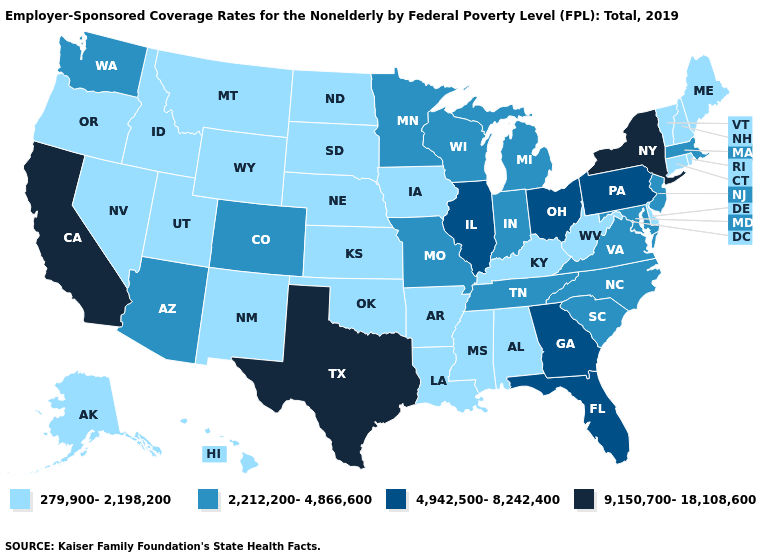Does Louisiana have the lowest value in the South?
Be succinct. Yes. Name the states that have a value in the range 279,900-2,198,200?
Give a very brief answer. Alabama, Alaska, Arkansas, Connecticut, Delaware, Hawaii, Idaho, Iowa, Kansas, Kentucky, Louisiana, Maine, Mississippi, Montana, Nebraska, Nevada, New Hampshire, New Mexico, North Dakota, Oklahoma, Oregon, Rhode Island, South Dakota, Utah, Vermont, West Virginia, Wyoming. What is the value of Iowa?
Concise answer only. 279,900-2,198,200. Name the states that have a value in the range 2,212,200-4,866,600?
Answer briefly. Arizona, Colorado, Indiana, Maryland, Massachusetts, Michigan, Minnesota, Missouri, New Jersey, North Carolina, South Carolina, Tennessee, Virginia, Washington, Wisconsin. What is the value of North Dakota?
Write a very short answer. 279,900-2,198,200. What is the lowest value in states that border Montana?
Quick response, please. 279,900-2,198,200. How many symbols are there in the legend?
Concise answer only. 4. Name the states that have a value in the range 9,150,700-18,108,600?
Short answer required. California, New York, Texas. Does Alabama have a lower value than South Dakota?
Give a very brief answer. No. What is the value of Connecticut?
Be succinct. 279,900-2,198,200. Name the states that have a value in the range 4,942,500-8,242,400?
Keep it brief. Florida, Georgia, Illinois, Ohio, Pennsylvania. What is the highest value in the MidWest ?
Give a very brief answer. 4,942,500-8,242,400. Name the states that have a value in the range 2,212,200-4,866,600?
Short answer required. Arizona, Colorado, Indiana, Maryland, Massachusetts, Michigan, Minnesota, Missouri, New Jersey, North Carolina, South Carolina, Tennessee, Virginia, Washington, Wisconsin. What is the value of Texas?
Short answer required. 9,150,700-18,108,600. What is the value of Alabama?
Write a very short answer. 279,900-2,198,200. 